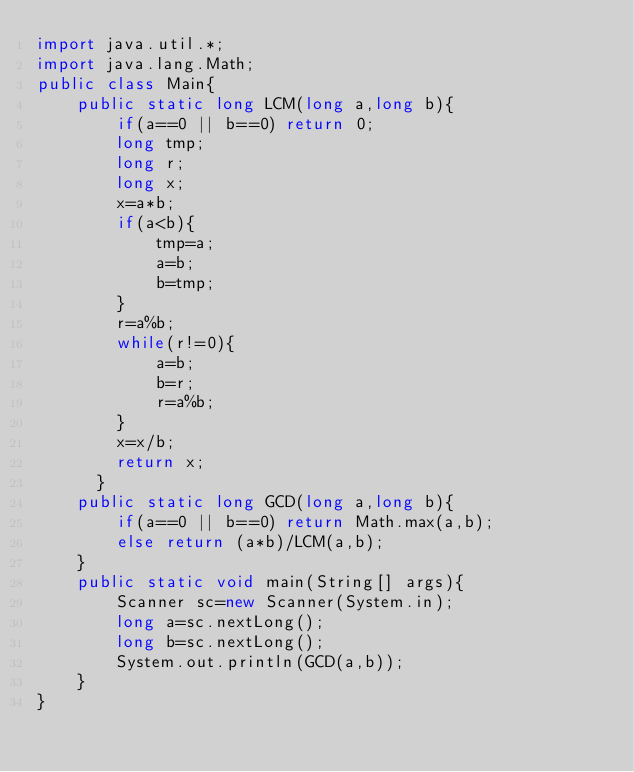<code> <loc_0><loc_0><loc_500><loc_500><_Java_>import java.util.*;
import java.lang.Math;
public class Main{
    public static long LCM(long a,long b){
        if(a==0 || b==0) return 0;
        long tmp;
        long r;
        long x;
        x=a*b;
        if(a<b){
            tmp=a;
            a=b;
            b=tmp;
        }
        r=a%b;
        while(r!=0){
            a=b;
            b=r;
            r=a%b;
        }
        x=x/b;
        return x;
      }
    public static long GCD(long a,long b){
        if(a==0 || b==0) return Math.max(a,b);
        else return (a*b)/LCM(a,b);
    }
    public static void main(String[] args){
        Scanner sc=new Scanner(System.in);
        long a=sc.nextLong();
        long b=sc.nextLong();
        System.out.println(GCD(a,b));
    }
}
</code> 